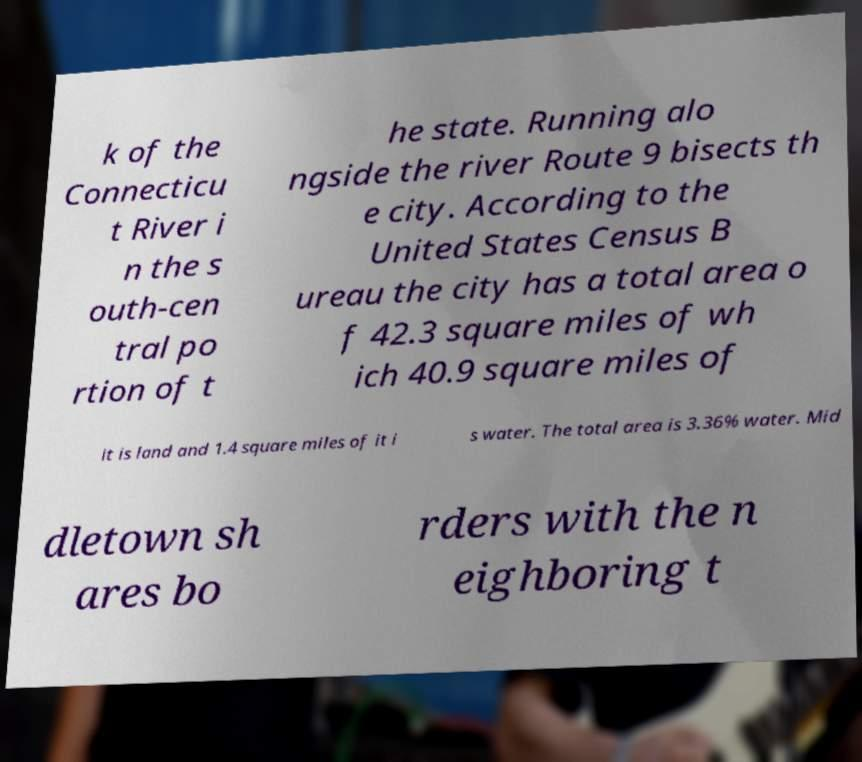I need the written content from this picture converted into text. Can you do that? k of the Connecticu t River i n the s outh-cen tral po rtion of t he state. Running alo ngside the river Route 9 bisects th e city. According to the United States Census B ureau the city has a total area o f 42.3 square miles of wh ich 40.9 square miles of it is land and 1.4 square miles of it i s water. The total area is 3.36% water. Mid dletown sh ares bo rders with the n eighboring t 